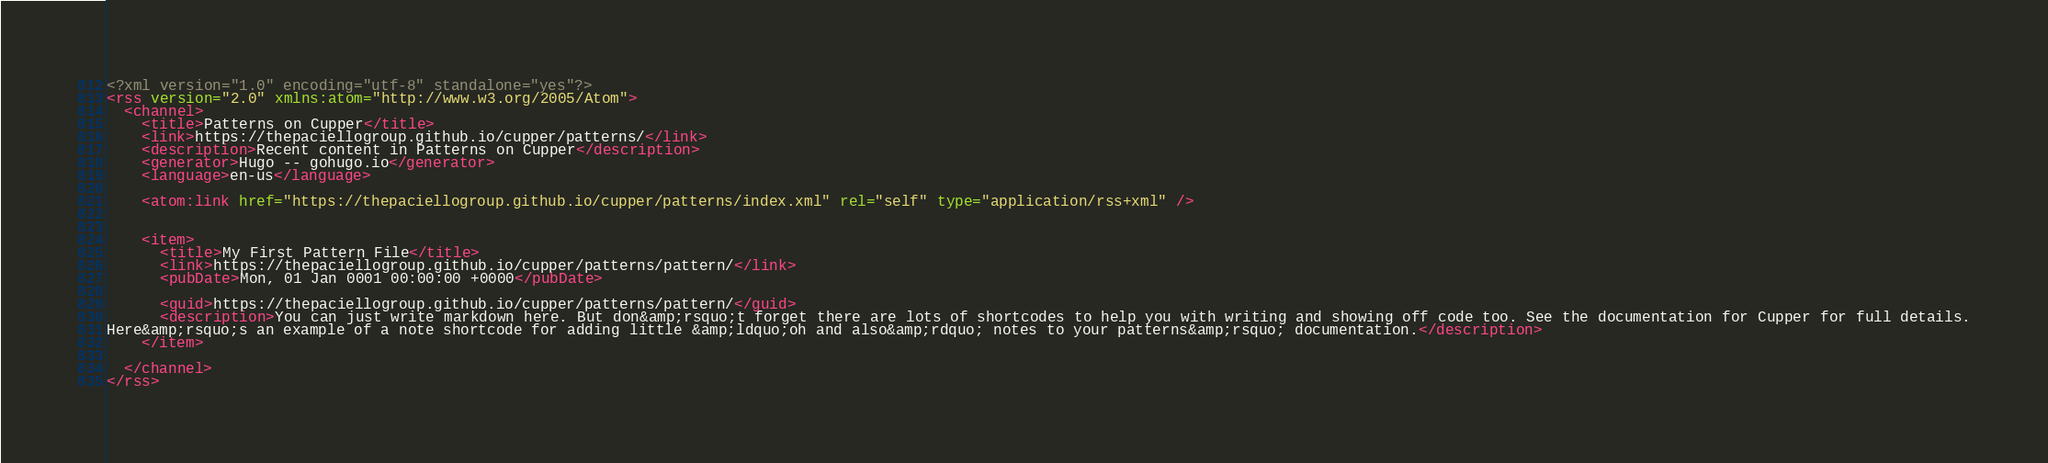<code> <loc_0><loc_0><loc_500><loc_500><_XML_><?xml version="1.0" encoding="utf-8" standalone="yes"?>
<rss version="2.0" xmlns:atom="http://www.w3.org/2005/Atom">
  <channel>
    <title>Patterns on Cupper</title>
    <link>https://thepaciellogroup.github.io/cupper/patterns/</link>
    <description>Recent content in Patterns on Cupper</description>
    <generator>Hugo -- gohugo.io</generator>
    <language>en-us</language>
    
	<atom:link href="https://thepaciellogroup.github.io/cupper/patterns/index.xml" rel="self" type="application/rss+xml" />
    
    
    <item>
      <title>My First Pattern File</title>
      <link>https://thepaciellogroup.github.io/cupper/patterns/pattern/</link>
      <pubDate>Mon, 01 Jan 0001 00:00:00 +0000</pubDate>
      
      <guid>https://thepaciellogroup.github.io/cupper/patterns/pattern/</guid>
      <description>You can just write markdown here. But don&amp;rsquo;t forget there are lots of shortcodes to help you with writing and showing off code too. See the documentation for Cupper for full details.
Here&amp;rsquo;s an example of a note shortcode for adding little &amp;ldquo;oh and also&amp;rdquo; notes to your patterns&amp;rsquo; documentation.</description>
    </item>
    
  </channel>
</rss></code> 